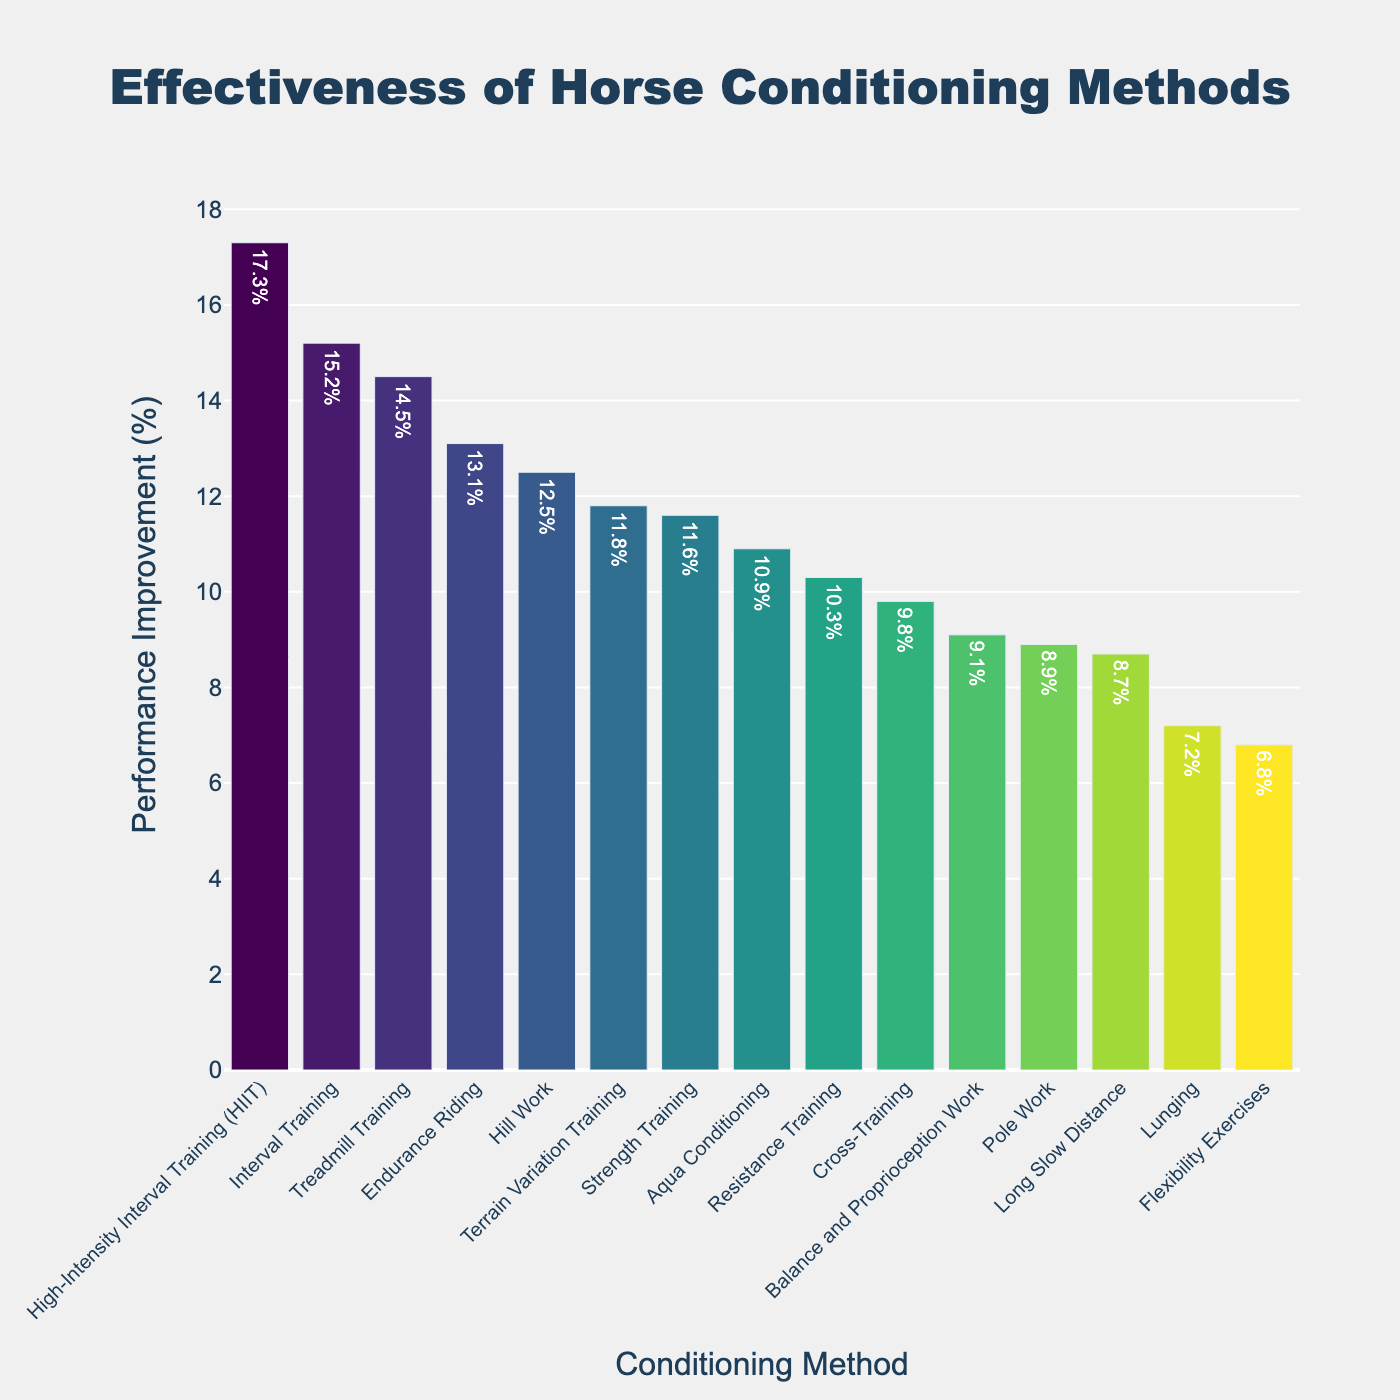Which conditioning method shows the highest performance improvement? Identify the bar with the maximum height which represents the highest performance improvement percentage. The tallest bar corresponds to High-Intensity Interval Training (HIIT) with a performance improvement of 17.3%.
Answer: High-Intensity Interval Training (HIIT) Which method has the lowest performance improvement? Find the bar with the minimum height indicating the lowest performance improvement. The shortest bar represents Flexibility Exercises with a performance improvement of 6.8%.
Answer: Flexibility Exercises What is the difference in performance improvement between Interval Training and Long Slow Distance? Look at the height of the bars for Interval Training and Long Slow Distance. Interval Training has a performance improvement of 15.2% and Long Slow Distance has 8.7%. The difference is 15.2% - 8.7% = 6.5%.
Answer: 6.5% Which methods have performance improvements greater than 10%? Identify the bars that are taller than the 10% mark on the y-axis. The methods are Interval Training, Hill Work, High-Intensity Interval Training (HIIT), Strength Training, Endurance Riding, Treadmill Training, and Terrain Variation Training.
Answer: Interval Training, Hill Work, High-Intensity Interval Training (HIIT), Strength Training, Endurance Riding, Treadmill Training, Terrain Variation Training How many methods have a performance improvement between 8% and 12%? Count the bars that fall between the 8% and 12% marks on the y-axis. The methods are Long Slow Distance, Cross-Training, Aqua Conditioning, Pole Work, Lunging, and Resistance Training. There are 6 methods in total within this range.
Answer: 6 What is the total performance improvement for Strength Training and Aqua Conditioning combined? Add up the performance improvements of Strength Training (11.6%) and Aqua Conditioning (10.9%). 11.6% + 10.9% = 22.5%.
Answer: 22.5% Which has a higher performance improvement: Treadmill Training or Endurance Riding? Compare the height of the bars for Treadmill Training and Endurance Riding. Treadmill Training has a performance improvement of 14.5% whereas Endurance Riding has 13.1%. Treadmill Training is higher.
Answer: Treadmill Training What is the median performance improvement of the conditioning methods? To find the median, sort the performance improvement percentages and find the middle value. The sorted improvements are 6.8%, 7.2%, 8.7%, 8.9%, 9.1%, 9.8%, 10.3%, 10.9%, 11.6%, 11.8%, 12.5%, 13.1%, 14.5%, 15.2%, 17.3%. The median is the 8th value, which is 10.9%.
Answer: 10.9% What is the average performance improvement across all methods? Add all performance improvement percentages and divide by the number of methods. The sum is 189.9%, and there are 15 methods, so the average is 189.9 / 15 = 12.66%.
Answer: 12.66% What is the range of performance improvement percentages across all methods? Subtract the smallest performance improvement percentage from the largest one. The range is 17.3% (highest) - 6.8% (lowest) = 10.5%.
Answer: 10.5% 